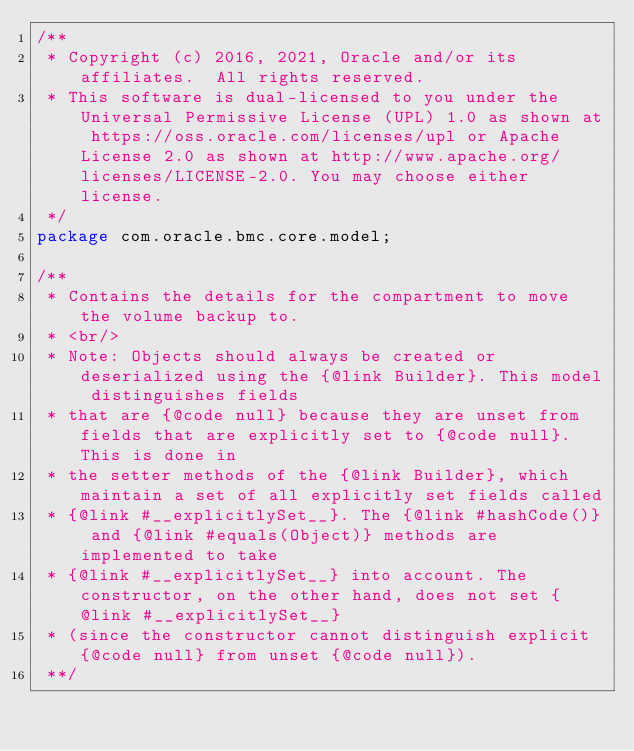<code> <loc_0><loc_0><loc_500><loc_500><_Java_>/**
 * Copyright (c) 2016, 2021, Oracle and/or its affiliates.  All rights reserved.
 * This software is dual-licensed to you under the Universal Permissive License (UPL) 1.0 as shown at https://oss.oracle.com/licenses/upl or Apache License 2.0 as shown at http://www.apache.org/licenses/LICENSE-2.0. You may choose either license.
 */
package com.oracle.bmc.core.model;

/**
 * Contains the details for the compartment to move the volume backup to.
 * <br/>
 * Note: Objects should always be created or deserialized using the {@link Builder}. This model distinguishes fields
 * that are {@code null} because they are unset from fields that are explicitly set to {@code null}. This is done in
 * the setter methods of the {@link Builder}, which maintain a set of all explicitly set fields called
 * {@link #__explicitlySet__}. The {@link #hashCode()} and {@link #equals(Object)} methods are implemented to take
 * {@link #__explicitlySet__} into account. The constructor, on the other hand, does not set {@link #__explicitlySet__}
 * (since the constructor cannot distinguish explicit {@code null} from unset {@code null}).
 **/</code> 